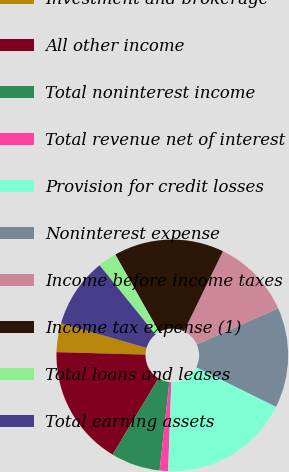Convert chart to OTSL. <chart><loc_0><loc_0><loc_500><loc_500><pie_chart><fcel>Investment and brokerage<fcel>All other income<fcel>Total noninterest income<fcel>Total revenue net of interest<fcel>Provision for credit losses<fcel>Noninterest expense<fcel>Income before income taxes<fcel>Income tax expense (1)<fcel>Total loans and leases<fcel>Total earning assets<nl><fcel>4.03%<fcel>16.82%<fcel>6.87%<fcel>1.18%<fcel>18.25%<fcel>13.98%<fcel>11.14%<fcel>15.4%<fcel>2.61%<fcel>9.72%<nl></chart> 